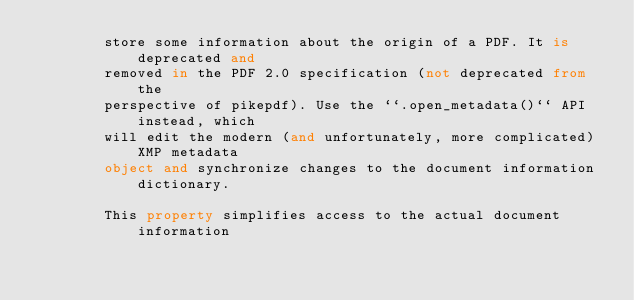<code> <loc_0><loc_0><loc_500><loc_500><_Python_>        store some information about the origin of a PDF. It is deprecated and
        removed in the PDF 2.0 specification (not deprecated from the
        perspective of pikepdf). Use the ``.open_metadata()`` API instead, which
        will edit the modern (and unfortunately, more complicated) XMP metadata
        object and synchronize changes to the document information dictionary.

        This property simplifies access to the actual document information</code> 